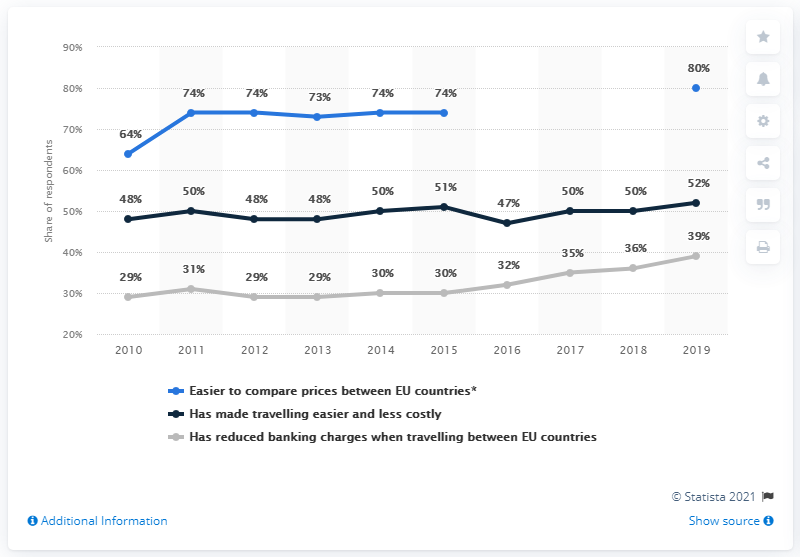Indicate a few pertinent items in this graphic. For 2 years, the black line above 50% has persisted. The black line reached its peak in 2019. 